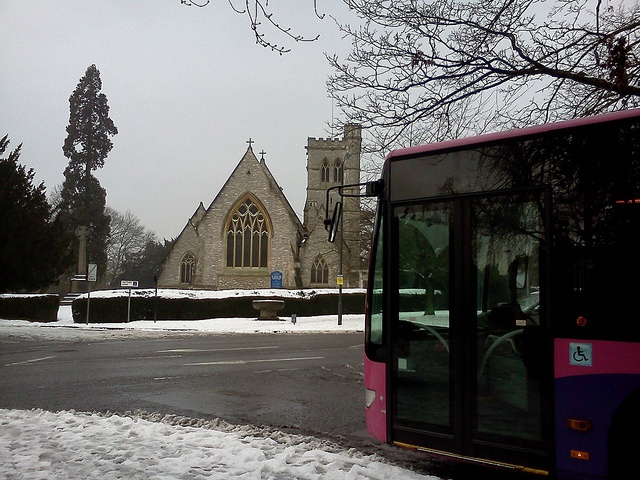Describe the objects in this image and their specific colors. I can see bus in lightgray, black, maroon, gray, and brown tones in this image. 